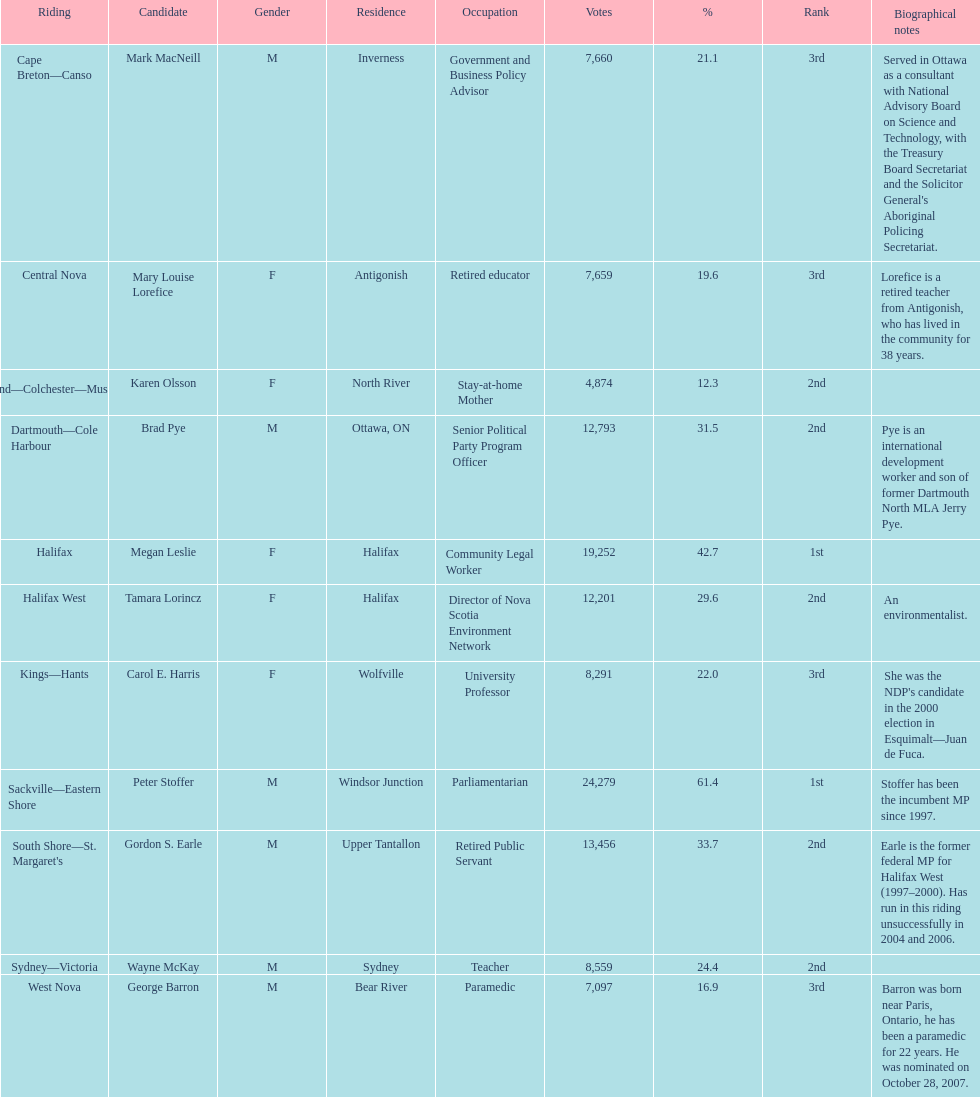What's the sum of all the candidates? 11. 